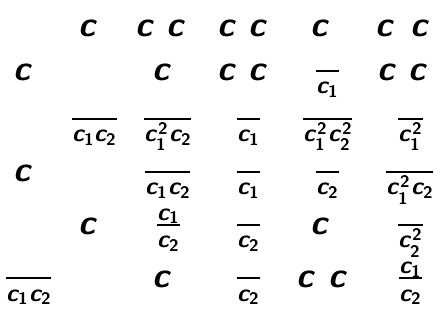<formula> <loc_0><loc_0><loc_500><loc_500>\begin{matrix} 1 & c _ { 2 } & c _ { 1 } c _ { 2 } ^ { 2 } & c _ { 1 } c _ { 2 } & c _ { 2 } ^ { 2 } & c _ { 1 } ^ { 2 } c _ { 2 } ^ { 2 } \\ c _ { 1 } & 1 & c _ { 2 } & c _ { 1 } c _ { 2 } & \frac { 1 } { c _ { 1 } } & c _ { 1 } c _ { 2 } ^ { 2 } \\ 1 & \frac { 1 } { c _ { 1 } c _ { 2 } } & \frac { 1 } { c _ { 1 } ^ { 2 } c _ { 2 } } & \frac { 1 } { c _ { 1 } } & \frac { 1 } { c _ { 1 } ^ { 2 } c _ { 2 } ^ { 2 } } & \frac { 1 } { c _ { 1 } ^ { 2 } } \\ c _ { 2 } & 1 & \frac { 1 } { c _ { 1 } c _ { 2 } } & \frac { 1 } { c _ { 1 } } & \frac { 1 } { c _ { 2 } } & \frac { 1 } { c _ { 1 } ^ { 2 } c _ { 2 } } \\ 1 & c _ { 1 } & \frac { c _ { 1 } } { c _ { 2 } } & \frac { 1 } { c _ { 2 } } & c _ { 1 } ^ { 2 } & \frac { 1 } { c _ { 2 } ^ { 2 } } \\ \frac { 1 } { c _ { 1 } c _ { 2 } } & 1 & c _ { 1 } & \frac { 1 } { c _ { 2 } } & c _ { 1 } c _ { 2 } & \frac { c _ { 1 } } { c _ { 2 } } \end{matrix}</formula> 